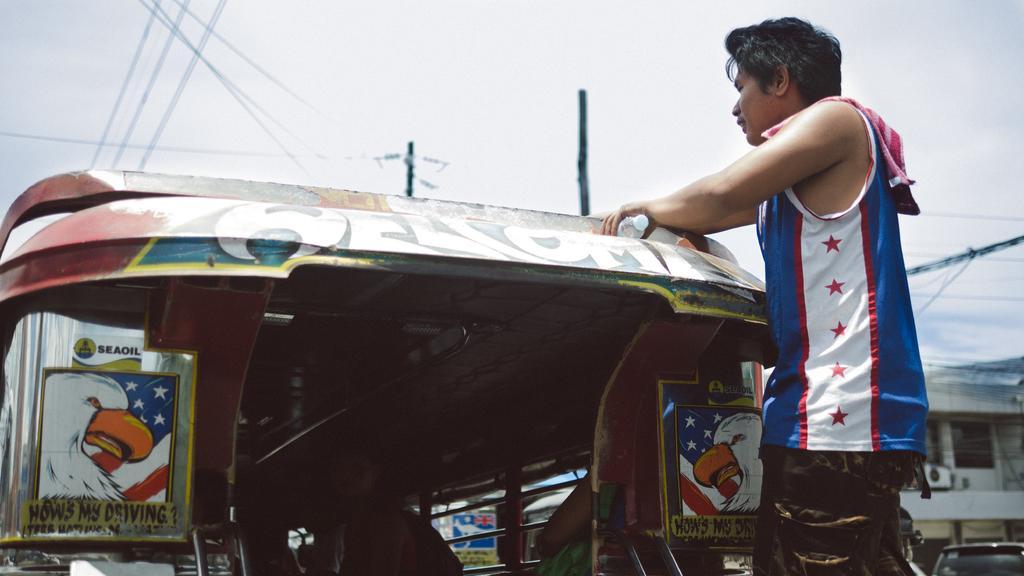Can you describe this image briefly? In this image we can see a man on the right side and he is standing on the back of a vehicle. Here we can see a person in the vehicle. This is looking like an electric pole and here we can see the electric wires. Here we can see a car on the bottom right side. Here we can see the house on the right side. 